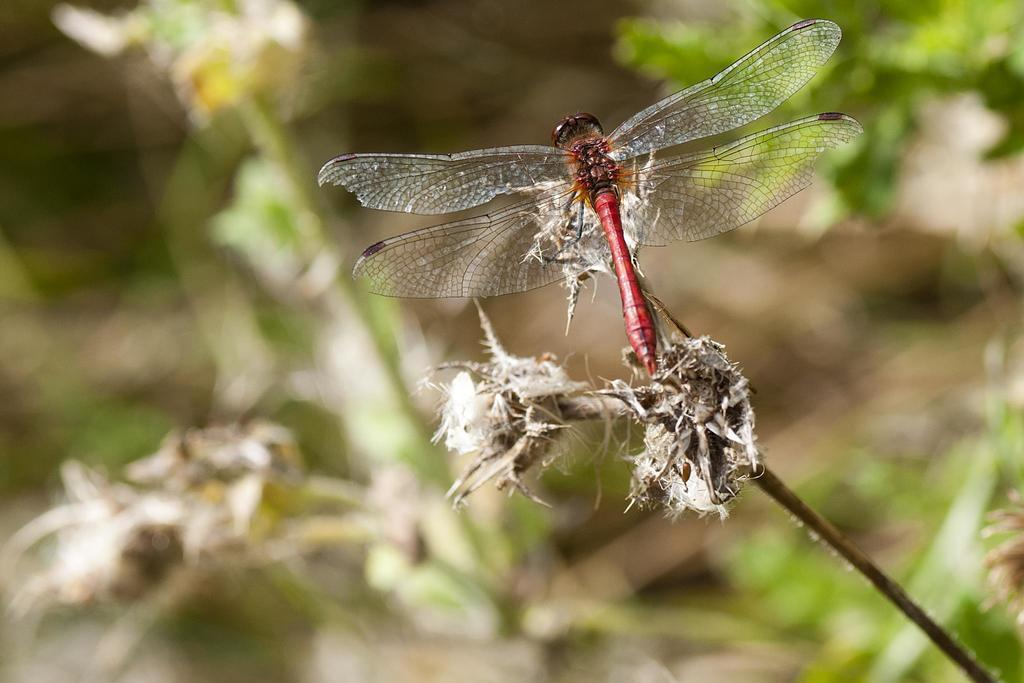What is present in the image? There is an insect in the image. Where is the insect located? The insect is on a flower. Can you describe the background of the image? The background of the image is blurred. What type of collar can be seen on the ant in the image? There is no ant present in the image, and therefore no collar can be seen on an ant. 